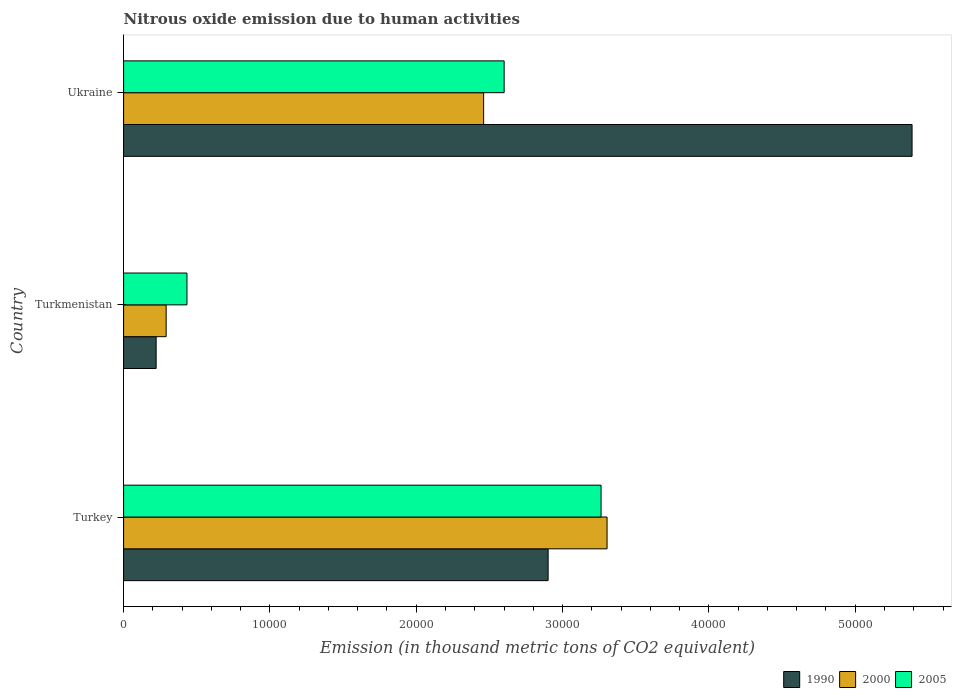How many different coloured bars are there?
Offer a terse response. 3. How many groups of bars are there?
Offer a very short reply. 3. Are the number of bars on each tick of the Y-axis equal?
Offer a very short reply. Yes. How many bars are there on the 2nd tick from the top?
Offer a very short reply. 3. How many bars are there on the 2nd tick from the bottom?
Ensure brevity in your answer.  3. What is the label of the 2nd group of bars from the top?
Ensure brevity in your answer.  Turkmenistan. What is the amount of nitrous oxide emitted in 1990 in Turkey?
Your answer should be very brief. 2.90e+04. Across all countries, what is the maximum amount of nitrous oxide emitted in 1990?
Your answer should be very brief. 5.39e+04. Across all countries, what is the minimum amount of nitrous oxide emitted in 2005?
Make the answer very short. 4330.6. In which country was the amount of nitrous oxide emitted in 2000 minimum?
Offer a very short reply. Turkmenistan. What is the total amount of nitrous oxide emitted in 1990 in the graph?
Provide a short and direct response. 8.51e+04. What is the difference between the amount of nitrous oxide emitted in 1990 in Turkmenistan and that in Ukraine?
Offer a terse response. -5.17e+04. What is the difference between the amount of nitrous oxide emitted in 2000 in Turkmenistan and the amount of nitrous oxide emitted in 2005 in Turkey?
Ensure brevity in your answer.  -2.97e+04. What is the average amount of nitrous oxide emitted in 2000 per country?
Your answer should be compact. 2.02e+04. What is the difference between the amount of nitrous oxide emitted in 1990 and amount of nitrous oxide emitted in 2000 in Turkey?
Offer a very short reply. -4027.6. What is the ratio of the amount of nitrous oxide emitted in 1990 in Turkmenistan to that in Ukraine?
Ensure brevity in your answer.  0.04. Is the difference between the amount of nitrous oxide emitted in 1990 in Turkmenistan and Ukraine greater than the difference between the amount of nitrous oxide emitted in 2000 in Turkmenistan and Ukraine?
Your answer should be very brief. No. What is the difference between the highest and the second highest amount of nitrous oxide emitted in 1990?
Provide a succinct answer. 2.49e+04. What is the difference between the highest and the lowest amount of nitrous oxide emitted in 2005?
Provide a short and direct response. 2.83e+04. In how many countries, is the amount of nitrous oxide emitted in 1990 greater than the average amount of nitrous oxide emitted in 1990 taken over all countries?
Make the answer very short. 2. What does the 2nd bar from the top in Turkmenistan represents?
Your response must be concise. 2000. Is it the case that in every country, the sum of the amount of nitrous oxide emitted in 1990 and amount of nitrous oxide emitted in 2000 is greater than the amount of nitrous oxide emitted in 2005?
Provide a succinct answer. Yes. How many bars are there?
Give a very brief answer. 9. How many countries are there in the graph?
Keep it short and to the point. 3. How are the legend labels stacked?
Your answer should be compact. Horizontal. What is the title of the graph?
Offer a terse response. Nitrous oxide emission due to human activities. Does "1983" appear as one of the legend labels in the graph?
Offer a very short reply. No. What is the label or title of the X-axis?
Give a very brief answer. Emission (in thousand metric tons of CO2 equivalent). What is the Emission (in thousand metric tons of CO2 equivalent) of 1990 in Turkey?
Give a very brief answer. 2.90e+04. What is the Emission (in thousand metric tons of CO2 equivalent) of 2000 in Turkey?
Your response must be concise. 3.30e+04. What is the Emission (in thousand metric tons of CO2 equivalent) of 2005 in Turkey?
Keep it short and to the point. 3.26e+04. What is the Emission (in thousand metric tons of CO2 equivalent) of 1990 in Turkmenistan?
Give a very brief answer. 2225.1. What is the Emission (in thousand metric tons of CO2 equivalent) in 2000 in Turkmenistan?
Provide a succinct answer. 2907.9. What is the Emission (in thousand metric tons of CO2 equivalent) of 2005 in Turkmenistan?
Your answer should be compact. 4330.6. What is the Emission (in thousand metric tons of CO2 equivalent) in 1990 in Ukraine?
Keep it short and to the point. 5.39e+04. What is the Emission (in thousand metric tons of CO2 equivalent) of 2000 in Ukraine?
Ensure brevity in your answer.  2.46e+04. What is the Emission (in thousand metric tons of CO2 equivalent) in 2005 in Ukraine?
Provide a succinct answer. 2.60e+04. Across all countries, what is the maximum Emission (in thousand metric tons of CO2 equivalent) in 1990?
Your response must be concise. 5.39e+04. Across all countries, what is the maximum Emission (in thousand metric tons of CO2 equivalent) in 2000?
Give a very brief answer. 3.30e+04. Across all countries, what is the maximum Emission (in thousand metric tons of CO2 equivalent) of 2005?
Give a very brief answer. 3.26e+04. Across all countries, what is the minimum Emission (in thousand metric tons of CO2 equivalent) of 1990?
Give a very brief answer. 2225.1. Across all countries, what is the minimum Emission (in thousand metric tons of CO2 equivalent) of 2000?
Offer a terse response. 2907.9. Across all countries, what is the minimum Emission (in thousand metric tons of CO2 equivalent) of 2005?
Your answer should be compact. 4330.6. What is the total Emission (in thousand metric tons of CO2 equivalent) of 1990 in the graph?
Offer a very short reply. 8.51e+04. What is the total Emission (in thousand metric tons of CO2 equivalent) in 2000 in the graph?
Ensure brevity in your answer.  6.06e+04. What is the total Emission (in thousand metric tons of CO2 equivalent) of 2005 in the graph?
Offer a very short reply. 6.30e+04. What is the difference between the Emission (in thousand metric tons of CO2 equivalent) in 1990 in Turkey and that in Turkmenistan?
Your answer should be very brief. 2.68e+04. What is the difference between the Emission (in thousand metric tons of CO2 equivalent) of 2000 in Turkey and that in Turkmenistan?
Make the answer very short. 3.01e+04. What is the difference between the Emission (in thousand metric tons of CO2 equivalent) of 2005 in Turkey and that in Turkmenistan?
Keep it short and to the point. 2.83e+04. What is the difference between the Emission (in thousand metric tons of CO2 equivalent) of 1990 in Turkey and that in Ukraine?
Offer a terse response. -2.49e+04. What is the difference between the Emission (in thousand metric tons of CO2 equivalent) in 2000 in Turkey and that in Ukraine?
Provide a succinct answer. 8435.4. What is the difference between the Emission (in thousand metric tons of CO2 equivalent) in 2005 in Turkey and that in Ukraine?
Provide a short and direct response. 6623.1. What is the difference between the Emission (in thousand metric tons of CO2 equivalent) in 1990 in Turkmenistan and that in Ukraine?
Your response must be concise. -5.17e+04. What is the difference between the Emission (in thousand metric tons of CO2 equivalent) in 2000 in Turkmenistan and that in Ukraine?
Provide a succinct answer. -2.17e+04. What is the difference between the Emission (in thousand metric tons of CO2 equivalent) of 2005 in Turkmenistan and that in Ukraine?
Your answer should be very brief. -2.17e+04. What is the difference between the Emission (in thousand metric tons of CO2 equivalent) in 1990 in Turkey and the Emission (in thousand metric tons of CO2 equivalent) in 2000 in Turkmenistan?
Give a very brief answer. 2.61e+04. What is the difference between the Emission (in thousand metric tons of CO2 equivalent) in 1990 in Turkey and the Emission (in thousand metric tons of CO2 equivalent) in 2005 in Turkmenistan?
Offer a terse response. 2.47e+04. What is the difference between the Emission (in thousand metric tons of CO2 equivalent) in 2000 in Turkey and the Emission (in thousand metric tons of CO2 equivalent) in 2005 in Turkmenistan?
Offer a terse response. 2.87e+04. What is the difference between the Emission (in thousand metric tons of CO2 equivalent) of 1990 in Turkey and the Emission (in thousand metric tons of CO2 equivalent) of 2000 in Ukraine?
Provide a succinct answer. 4407.8. What is the difference between the Emission (in thousand metric tons of CO2 equivalent) in 1990 in Turkey and the Emission (in thousand metric tons of CO2 equivalent) in 2005 in Ukraine?
Offer a terse response. 3005.7. What is the difference between the Emission (in thousand metric tons of CO2 equivalent) in 2000 in Turkey and the Emission (in thousand metric tons of CO2 equivalent) in 2005 in Ukraine?
Your response must be concise. 7033.3. What is the difference between the Emission (in thousand metric tons of CO2 equivalent) of 1990 in Turkmenistan and the Emission (in thousand metric tons of CO2 equivalent) of 2000 in Ukraine?
Keep it short and to the point. -2.24e+04. What is the difference between the Emission (in thousand metric tons of CO2 equivalent) in 1990 in Turkmenistan and the Emission (in thousand metric tons of CO2 equivalent) in 2005 in Ukraine?
Your response must be concise. -2.38e+04. What is the difference between the Emission (in thousand metric tons of CO2 equivalent) in 2000 in Turkmenistan and the Emission (in thousand metric tons of CO2 equivalent) in 2005 in Ukraine?
Provide a short and direct response. -2.31e+04. What is the average Emission (in thousand metric tons of CO2 equivalent) in 1990 per country?
Your answer should be very brief. 2.84e+04. What is the average Emission (in thousand metric tons of CO2 equivalent) in 2000 per country?
Provide a succinct answer. 2.02e+04. What is the average Emission (in thousand metric tons of CO2 equivalent) in 2005 per country?
Offer a very short reply. 2.10e+04. What is the difference between the Emission (in thousand metric tons of CO2 equivalent) in 1990 and Emission (in thousand metric tons of CO2 equivalent) in 2000 in Turkey?
Offer a very short reply. -4027.6. What is the difference between the Emission (in thousand metric tons of CO2 equivalent) in 1990 and Emission (in thousand metric tons of CO2 equivalent) in 2005 in Turkey?
Give a very brief answer. -3617.4. What is the difference between the Emission (in thousand metric tons of CO2 equivalent) of 2000 and Emission (in thousand metric tons of CO2 equivalent) of 2005 in Turkey?
Provide a short and direct response. 410.2. What is the difference between the Emission (in thousand metric tons of CO2 equivalent) of 1990 and Emission (in thousand metric tons of CO2 equivalent) of 2000 in Turkmenistan?
Provide a succinct answer. -682.8. What is the difference between the Emission (in thousand metric tons of CO2 equivalent) in 1990 and Emission (in thousand metric tons of CO2 equivalent) in 2005 in Turkmenistan?
Offer a very short reply. -2105.5. What is the difference between the Emission (in thousand metric tons of CO2 equivalent) in 2000 and Emission (in thousand metric tons of CO2 equivalent) in 2005 in Turkmenistan?
Make the answer very short. -1422.7. What is the difference between the Emission (in thousand metric tons of CO2 equivalent) in 1990 and Emission (in thousand metric tons of CO2 equivalent) in 2000 in Ukraine?
Make the answer very short. 2.93e+04. What is the difference between the Emission (in thousand metric tons of CO2 equivalent) of 1990 and Emission (in thousand metric tons of CO2 equivalent) of 2005 in Ukraine?
Provide a succinct answer. 2.79e+04. What is the difference between the Emission (in thousand metric tons of CO2 equivalent) of 2000 and Emission (in thousand metric tons of CO2 equivalent) of 2005 in Ukraine?
Give a very brief answer. -1402.1. What is the ratio of the Emission (in thousand metric tons of CO2 equivalent) of 1990 in Turkey to that in Turkmenistan?
Give a very brief answer. 13.04. What is the ratio of the Emission (in thousand metric tons of CO2 equivalent) of 2000 in Turkey to that in Turkmenistan?
Make the answer very short. 11.36. What is the ratio of the Emission (in thousand metric tons of CO2 equivalent) of 2005 in Turkey to that in Turkmenistan?
Give a very brief answer. 7.54. What is the ratio of the Emission (in thousand metric tons of CO2 equivalent) of 1990 in Turkey to that in Ukraine?
Provide a succinct answer. 0.54. What is the ratio of the Emission (in thousand metric tons of CO2 equivalent) in 2000 in Turkey to that in Ukraine?
Offer a very short reply. 1.34. What is the ratio of the Emission (in thousand metric tons of CO2 equivalent) of 2005 in Turkey to that in Ukraine?
Your response must be concise. 1.25. What is the ratio of the Emission (in thousand metric tons of CO2 equivalent) in 1990 in Turkmenistan to that in Ukraine?
Keep it short and to the point. 0.04. What is the ratio of the Emission (in thousand metric tons of CO2 equivalent) of 2000 in Turkmenistan to that in Ukraine?
Offer a terse response. 0.12. What is the ratio of the Emission (in thousand metric tons of CO2 equivalent) of 2005 in Turkmenistan to that in Ukraine?
Provide a succinct answer. 0.17. What is the difference between the highest and the second highest Emission (in thousand metric tons of CO2 equivalent) of 1990?
Ensure brevity in your answer.  2.49e+04. What is the difference between the highest and the second highest Emission (in thousand metric tons of CO2 equivalent) of 2000?
Provide a succinct answer. 8435.4. What is the difference between the highest and the second highest Emission (in thousand metric tons of CO2 equivalent) of 2005?
Provide a succinct answer. 6623.1. What is the difference between the highest and the lowest Emission (in thousand metric tons of CO2 equivalent) of 1990?
Provide a succinct answer. 5.17e+04. What is the difference between the highest and the lowest Emission (in thousand metric tons of CO2 equivalent) of 2000?
Offer a very short reply. 3.01e+04. What is the difference between the highest and the lowest Emission (in thousand metric tons of CO2 equivalent) in 2005?
Offer a terse response. 2.83e+04. 